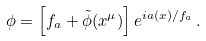<formula> <loc_0><loc_0><loc_500><loc_500>\phi = \left [ f _ { a } + \tilde { \phi } ( x ^ { \mu } ) \right ] e ^ { i a ( x ) / f _ { a } } \, .</formula> 